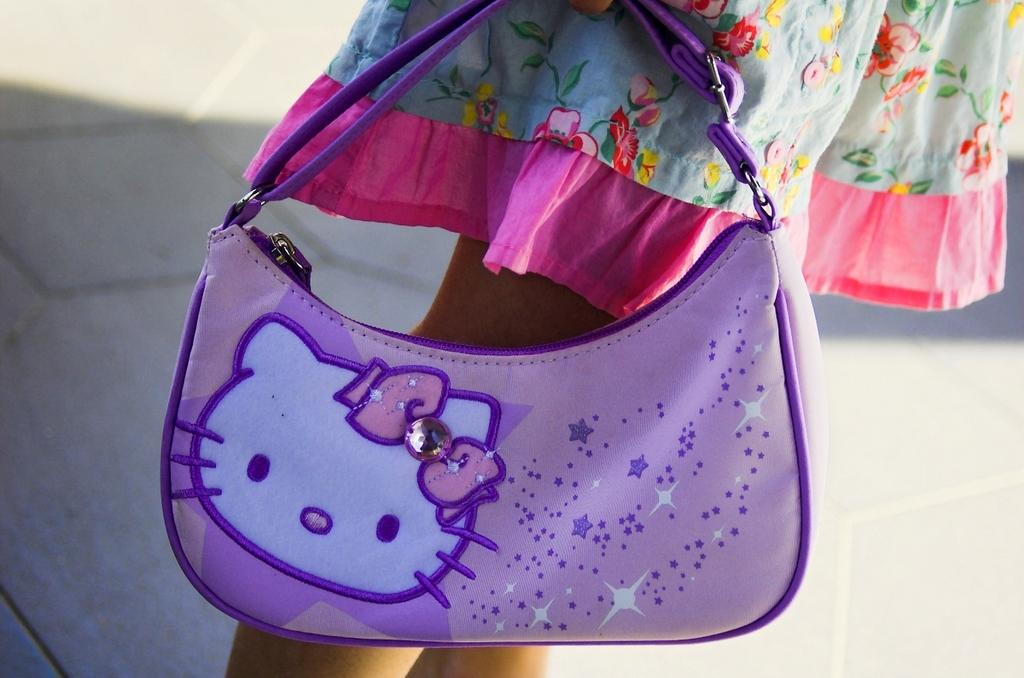What is the main subject of the image? The image depicts a road. Are there any people in the image? Yes, there is a person in the image. Can you describe the person's attire? The person is wearing a colorful dress. What is the person holding in the image? The person is holding a handbag. What color is the handbag? The handbag is purple in color. What type of toothpaste is the person using in the image? There is no toothpaste present in the image; it depicts a person on a road holding a purple handbag. 